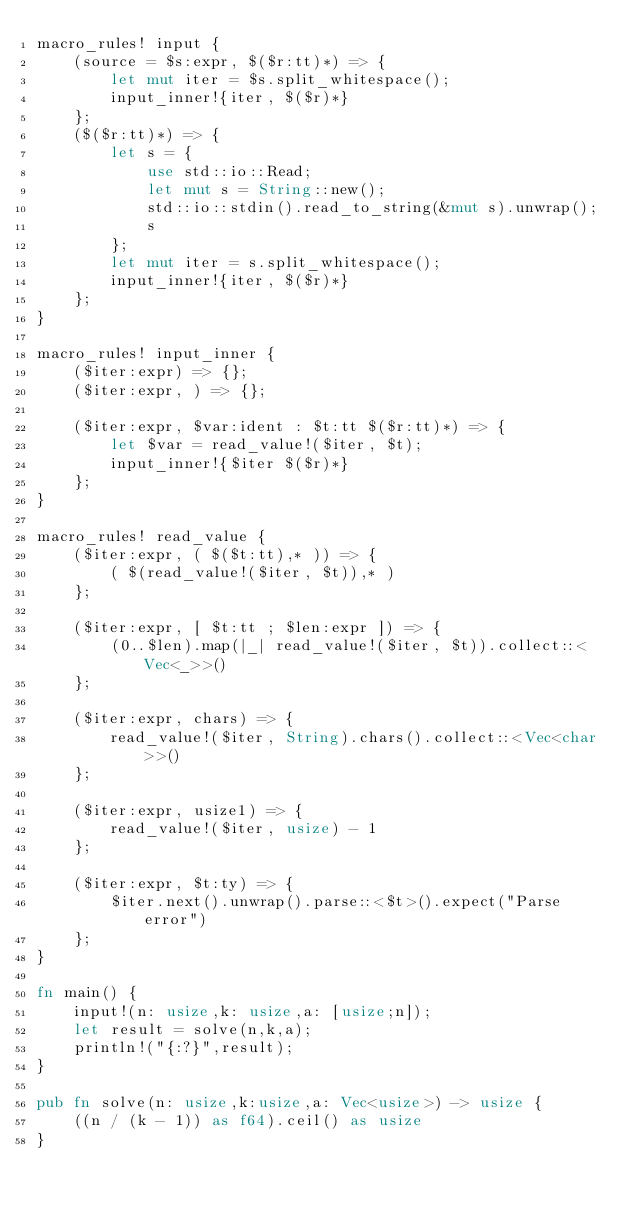Convert code to text. <code><loc_0><loc_0><loc_500><loc_500><_Rust_>macro_rules! input {
    (source = $s:expr, $($r:tt)*) => {
        let mut iter = $s.split_whitespace();
        input_inner!{iter, $($r)*}
    };
    ($($r:tt)*) => {
        let s = {
            use std::io::Read;
            let mut s = String::new();
            std::io::stdin().read_to_string(&mut s).unwrap();
            s
        };
        let mut iter = s.split_whitespace();
        input_inner!{iter, $($r)*}
    };
}

macro_rules! input_inner {
    ($iter:expr) => {};
    ($iter:expr, ) => {};

    ($iter:expr, $var:ident : $t:tt $($r:tt)*) => {
        let $var = read_value!($iter, $t);
        input_inner!{$iter $($r)*}
    };
}

macro_rules! read_value {
    ($iter:expr, ( $($t:tt),* )) => {
        ( $(read_value!($iter, $t)),* )
    };

    ($iter:expr, [ $t:tt ; $len:expr ]) => {
        (0..$len).map(|_| read_value!($iter, $t)).collect::<Vec<_>>()
    };

    ($iter:expr, chars) => {
        read_value!($iter, String).chars().collect::<Vec<char>>()
    };

    ($iter:expr, usize1) => {
        read_value!($iter, usize) - 1
    };

    ($iter:expr, $t:ty) => {
        $iter.next().unwrap().parse::<$t>().expect("Parse error")
    };
}

fn main() {
    input!(n: usize,k: usize,a: [usize;n]);
    let result = solve(n,k,a);
    println!("{:?}",result);
}

pub fn solve(n: usize,k:usize,a: Vec<usize>) -> usize {
    ((n / (k - 1)) as f64).ceil() as usize
}

       </code> 